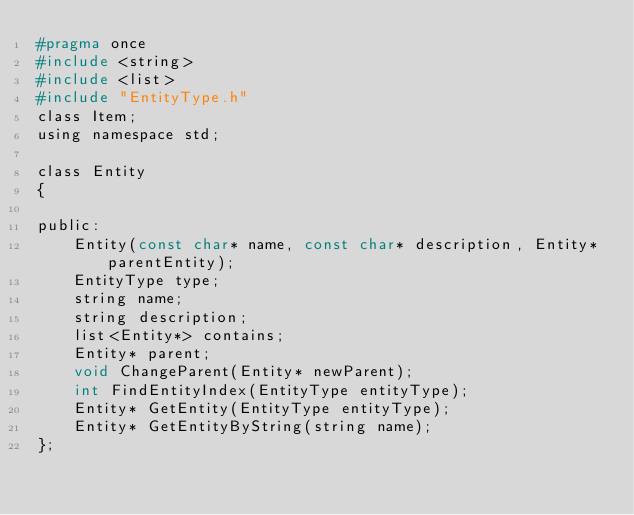Convert code to text. <code><loc_0><loc_0><loc_500><loc_500><_C_>#pragma once
#include <string>
#include <list>
#include "EntityType.h"
class Item;
using namespace std;

class Entity
{

public:
	Entity(const char* name, const char* description, Entity* parentEntity);
	EntityType type;
	string name;
	string description;
	list<Entity*> contains;
	Entity* parent;
	void ChangeParent(Entity* newParent);
	int FindEntityIndex(EntityType entityType);
	Entity* GetEntity(EntityType entityType);
	Entity* GetEntityByString(string name);
};

</code> 